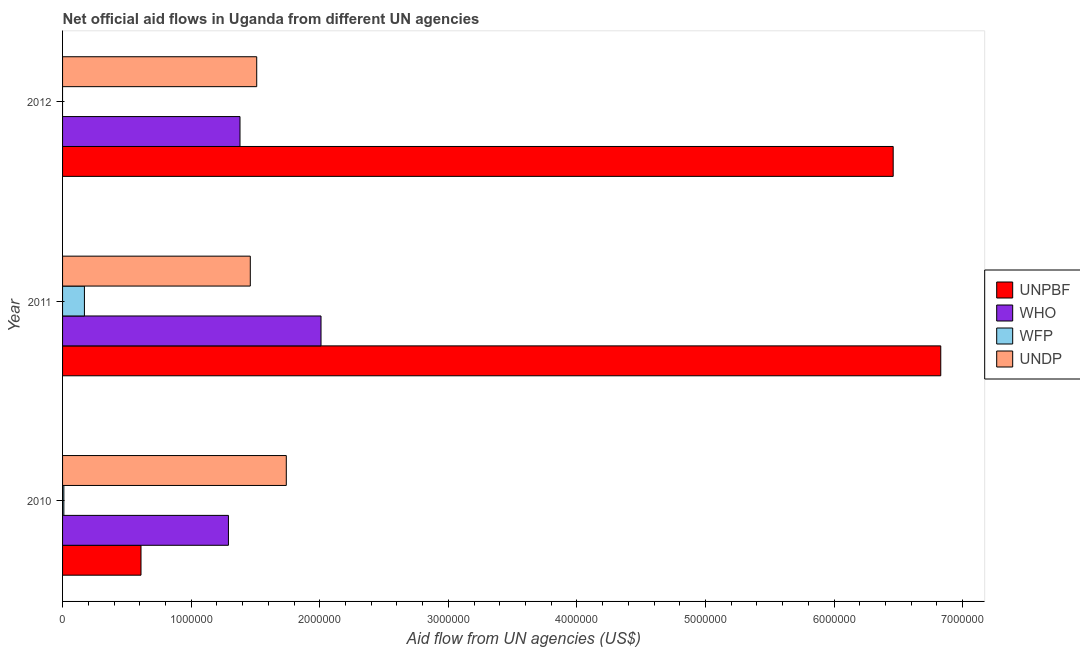How many groups of bars are there?
Your answer should be very brief. 3. Are the number of bars on each tick of the Y-axis equal?
Ensure brevity in your answer.  No. In how many cases, is the number of bars for a given year not equal to the number of legend labels?
Keep it short and to the point. 1. What is the amount of aid given by who in 2012?
Your response must be concise. 1.38e+06. Across all years, what is the maximum amount of aid given by wfp?
Provide a short and direct response. 1.70e+05. What is the total amount of aid given by who in the graph?
Your answer should be compact. 4.68e+06. What is the difference between the amount of aid given by who in 2010 and that in 2012?
Your answer should be very brief. -9.00e+04. What is the difference between the amount of aid given by who in 2012 and the amount of aid given by unpbf in 2011?
Your response must be concise. -5.45e+06. In the year 2010, what is the difference between the amount of aid given by undp and amount of aid given by who?
Offer a very short reply. 4.50e+05. What is the ratio of the amount of aid given by who in 2011 to that in 2012?
Your answer should be compact. 1.46. What is the difference between the highest and the lowest amount of aid given by unpbf?
Ensure brevity in your answer.  6.22e+06. Is it the case that in every year, the sum of the amount of aid given by unpbf and amount of aid given by who is greater than the amount of aid given by wfp?
Provide a succinct answer. Yes. Are all the bars in the graph horizontal?
Give a very brief answer. Yes. Are the values on the major ticks of X-axis written in scientific E-notation?
Your response must be concise. No. Does the graph contain any zero values?
Your response must be concise. Yes. How are the legend labels stacked?
Your answer should be very brief. Vertical. What is the title of the graph?
Make the answer very short. Net official aid flows in Uganda from different UN agencies. What is the label or title of the X-axis?
Provide a short and direct response. Aid flow from UN agencies (US$). What is the label or title of the Y-axis?
Ensure brevity in your answer.  Year. What is the Aid flow from UN agencies (US$) of WHO in 2010?
Provide a succinct answer. 1.29e+06. What is the Aid flow from UN agencies (US$) in UNDP in 2010?
Ensure brevity in your answer.  1.74e+06. What is the Aid flow from UN agencies (US$) of UNPBF in 2011?
Give a very brief answer. 6.83e+06. What is the Aid flow from UN agencies (US$) of WHO in 2011?
Your answer should be compact. 2.01e+06. What is the Aid flow from UN agencies (US$) in UNDP in 2011?
Make the answer very short. 1.46e+06. What is the Aid flow from UN agencies (US$) of UNPBF in 2012?
Provide a succinct answer. 6.46e+06. What is the Aid flow from UN agencies (US$) in WHO in 2012?
Keep it short and to the point. 1.38e+06. What is the Aid flow from UN agencies (US$) in WFP in 2012?
Provide a succinct answer. 0. What is the Aid flow from UN agencies (US$) in UNDP in 2012?
Ensure brevity in your answer.  1.51e+06. Across all years, what is the maximum Aid flow from UN agencies (US$) of UNPBF?
Your answer should be very brief. 6.83e+06. Across all years, what is the maximum Aid flow from UN agencies (US$) of WHO?
Provide a succinct answer. 2.01e+06. Across all years, what is the maximum Aid flow from UN agencies (US$) in UNDP?
Keep it short and to the point. 1.74e+06. Across all years, what is the minimum Aid flow from UN agencies (US$) of WHO?
Your answer should be very brief. 1.29e+06. Across all years, what is the minimum Aid flow from UN agencies (US$) in WFP?
Offer a terse response. 0. Across all years, what is the minimum Aid flow from UN agencies (US$) in UNDP?
Provide a short and direct response. 1.46e+06. What is the total Aid flow from UN agencies (US$) in UNPBF in the graph?
Offer a terse response. 1.39e+07. What is the total Aid flow from UN agencies (US$) of WHO in the graph?
Keep it short and to the point. 4.68e+06. What is the total Aid flow from UN agencies (US$) in UNDP in the graph?
Offer a very short reply. 4.71e+06. What is the difference between the Aid flow from UN agencies (US$) in UNPBF in 2010 and that in 2011?
Give a very brief answer. -6.22e+06. What is the difference between the Aid flow from UN agencies (US$) of WHO in 2010 and that in 2011?
Provide a short and direct response. -7.20e+05. What is the difference between the Aid flow from UN agencies (US$) of UNPBF in 2010 and that in 2012?
Provide a short and direct response. -5.85e+06. What is the difference between the Aid flow from UN agencies (US$) of UNDP in 2010 and that in 2012?
Make the answer very short. 2.30e+05. What is the difference between the Aid flow from UN agencies (US$) in WHO in 2011 and that in 2012?
Ensure brevity in your answer.  6.30e+05. What is the difference between the Aid flow from UN agencies (US$) of UNPBF in 2010 and the Aid flow from UN agencies (US$) of WHO in 2011?
Provide a succinct answer. -1.40e+06. What is the difference between the Aid flow from UN agencies (US$) in UNPBF in 2010 and the Aid flow from UN agencies (US$) in WFP in 2011?
Make the answer very short. 4.40e+05. What is the difference between the Aid flow from UN agencies (US$) of UNPBF in 2010 and the Aid flow from UN agencies (US$) of UNDP in 2011?
Offer a terse response. -8.50e+05. What is the difference between the Aid flow from UN agencies (US$) in WHO in 2010 and the Aid flow from UN agencies (US$) in WFP in 2011?
Your answer should be very brief. 1.12e+06. What is the difference between the Aid flow from UN agencies (US$) of WHO in 2010 and the Aid flow from UN agencies (US$) of UNDP in 2011?
Your answer should be compact. -1.70e+05. What is the difference between the Aid flow from UN agencies (US$) of WFP in 2010 and the Aid flow from UN agencies (US$) of UNDP in 2011?
Offer a very short reply. -1.45e+06. What is the difference between the Aid flow from UN agencies (US$) in UNPBF in 2010 and the Aid flow from UN agencies (US$) in WHO in 2012?
Make the answer very short. -7.70e+05. What is the difference between the Aid flow from UN agencies (US$) of UNPBF in 2010 and the Aid flow from UN agencies (US$) of UNDP in 2012?
Offer a very short reply. -9.00e+05. What is the difference between the Aid flow from UN agencies (US$) of WFP in 2010 and the Aid flow from UN agencies (US$) of UNDP in 2012?
Provide a short and direct response. -1.50e+06. What is the difference between the Aid flow from UN agencies (US$) of UNPBF in 2011 and the Aid flow from UN agencies (US$) of WHO in 2012?
Your response must be concise. 5.45e+06. What is the difference between the Aid flow from UN agencies (US$) of UNPBF in 2011 and the Aid flow from UN agencies (US$) of UNDP in 2012?
Provide a succinct answer. 5.32e+06. What is the difference between the Aid flow from UN agencies (US$) in WHO in 2011 and the Aid flow from UN agencies (US$) in UNDP in 2012?
Keep it short and to the point. 5.00e+05. What is the difference between the Aid flow from UN agencies (US$) in WFP in 2011 and the Aid flow from UN agencies (US$) in UNDP in 2012?
Keep it short and to the point. -1.34e+06. What is the average Aid flow from UN agencies (US$) of UNPBF per year?
Make the answer very short. 4.63e+06. What is the average Aid flow from UN agencies (US$) of WHO per year?
Your response must be concise. 1.56e+06. What is the average Aid flow from UN agencies (US$) of WFP per year?
Your response must be concise. 6.00e+04. What is the average Aid flow from UN agencies (US$) of UNDP per year?
Ensure brevity in your answer.  1.57e+06. In the year 2010, what is the difference between the Aid flow from UN agencies (US$) in UNPBF and Aid flow from UN agencies (US$) in WHO?
Offer a terse response. -6.80e+05. In the year 2010, what is the difference between the Aid flow from UN agencies (US$) in UNPBF and Aid flow from UN agencies (US$) in WFP?
Keep it short and to the point. 6.00e+05. In the year 2010, what is the difference between the Aid flow from UN agencies (US$) of UNPBF and Aid flow from UN agencies (US$) of UNDP?
Your answer should be very brief. -1.13e+06. In the year 2010, what is the difference between the Aid flow from UN agencies (US$) in WHO and Aid flow from UN agencies (US$) in WFP?
Provide a succinct answer. 1.28e+06. In the year 2010, what is the difference between the Aid flow from UN agencies (US$) in WHO and Aid flow from UN agencies (US$) in UNDP?
Give a very brief answer. -4.50e+05. In the year 2010, what is the difference between the Aid flow from UN agencies (US$) in WFP and Aid flow from UN agencies (US$) in UNDP?
Your answer should be very brief. -1.73e+06. In the year 2011, what is the difference between the Aid flow from UN agencies (US$) in UNPBF and Aid flow from UN agencies (US$) in WHO?
Keep it short and to the point. 4.82e+06. In the year 2011, what is the difference between the Aid flow from UN agencies (US$) of UNPBF and Aid flow from UN agencies (US$) of WFP?
Your answer should be very brief. 6.66e+06. In the year 2011, what is the difference between the Aid flow from UN agencies (US$) in UNPBF and Aid flow from UN agencies (US$) in UNDP?
Offer a terse response. 5.37e+06. In the year 2011, what is the difference between the Aid flow from UN agencies (US$) of WHO and Aid flow from UN agencies (US$) of WFP?
Your answer should be very brief. 1.84e+06. In the year 2011, what is the difference between the Aid flow from UN agencies (US$) of WHO and Aid flow from UN agencies (US$) of UNDP?
Provide a succinct answer. 5.50e+05. In the year 2011, what is the difference between the Aid flow from UN agencies (US$) of WFP and Aid flow from UN agencies (US$) of UNDP?
Ensure brevity in your answer.  -1.29e+06. In the year 2012, what is the difference between the Aid flow from UN agencies (US$) in UNPBF and Aid flow from UN agencies (US$) in WHO?
Make the answer very short. 5.08e+06. In the year 2012, what is the difference between the Aid flow from UN agencies (US$) in UNPBF and Aid flow from UN agencies (US$) in UNDP?
Your answer should be very brief. 4.95e+06. In the year 2012, what is the difference between the Aid flow from UN agencies (US$) in WHO and Aid flow from UN agencies (US$) in UNDP?
Offer a very short reply. -1.30e+05. What is the ratio of the Aid flow from UN agencies (US$) in UNPBF in 2010 to that in 2011?
Offer a terse response. 0.09. What is the ratio of the Aid flow from UN agencies (US$) of WHO in 2010 to that in 2011?
Make the answer very short. 0.64. What is the ratio of the Aid flow from UN agencies (US$) in WFP in 2010 to that in 2011?
Ensure brevity in your answer.  0.06. What is the ratio of the Aid flow from UN agencies (US$) of UNDP in 2010 to that in 2011?
Provide a short and direct response. 1.19. What is the ratio of the Aid flow from UN agencies (US$) of UNPBF in 2010 to that in 2012?
Provide a succinct answer. 0.09. What is the ratio of the Aid flow from UN agencies (US$) of WHO in 2010 to that in 2012?
Make the answer very short. 0.93. What is the ratio of the Aid flow from UN agencies (US$) of UNDP in 2010 to that in 2012?
Provide a short and direct response. 1.15. What is the ratio of the Aid flow from UN agencies (US$) in UNPBF in 2011 to that in 2012?
Your answer should be very brief. 1.06. What is the ratio of the Aid flow from UN agencies (US$) in WHO in 2011 to that in 2012?
Offer a terse response. 1.46. What is the ratio of the Aid flow from UN agencies (US$) in UNDP in 2011 to that in 2012?
Your answer should be compact. 0.97. What is the difference between the highest and the second highest Aid flow from UN agencies (US$) in UNPBF?
Provide a succinct answer. 3.70e+05. What is the difference between the highest and the second highest Aid flow from UN agencies (US$) in WHO?
Make the answer very short. 6.30e+05. What is the difference between the highest and the second highest Aid flow from UN agencies (US$) of UNDP?
Ensure brevity in your answer.  2.30e+05. What is the difference between the highest and the lowest Aid flow from UN agencies (US$) of UNPBF?
Your response must be concise. 6.22e+06. What is the difference between the highest and the lowest Aid flow from UN agencies (US$) in WHO?
Provide a short and direct response. 7.20e+05. 